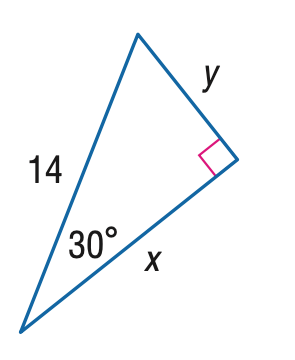Question: Find x.
Choices:
A. 7
B. 7 \sqrt { 2 }
C. 7 \sqrt { 3 }
D. 14
Answer with the letter. Answer: C 